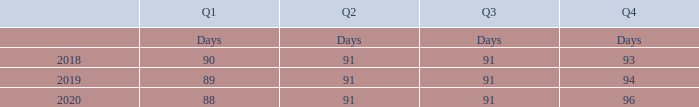Under Article 35 of our Articles of Association, our financial year extends from January 1 to December 31, which is the period end of each fiscal year. In 2019, the first quarter ended on March 30, the second quarter ended on June 29, the third quarter ended on September 28 and the fourth quarter ended on December 31.
In 2020, the first quarter will end on March 28, the second quarter will end on June 27, the third quarter will end on September 26 and the fourth quarter will end on December 31.
Based on our fiscal calendar, the distribution of our revenues and expenses by quarter may be unbalanced due to a different number of days in the various quarters of the fiscal year and can also differ from equivalent prior years’ periods, as illustrated in the below table for the years 2018, 2019 and 2020.
In 2019, when did the first quarter ended? March 30. In 2020, when did the first quarter ended? March 28. What is the annual calendar of the financial cycle? From january 1 to december 31. What are the average days in Q1? (90+89+88)/ 3
Answer: 89. What is the increase/ (decrease) in Q1 days from 2018 to 2020? 88-90
Answer: -2. What is the increase/ (decrease) in Q4 days from 2018 to 2020? 96-93
Answer: 3. 